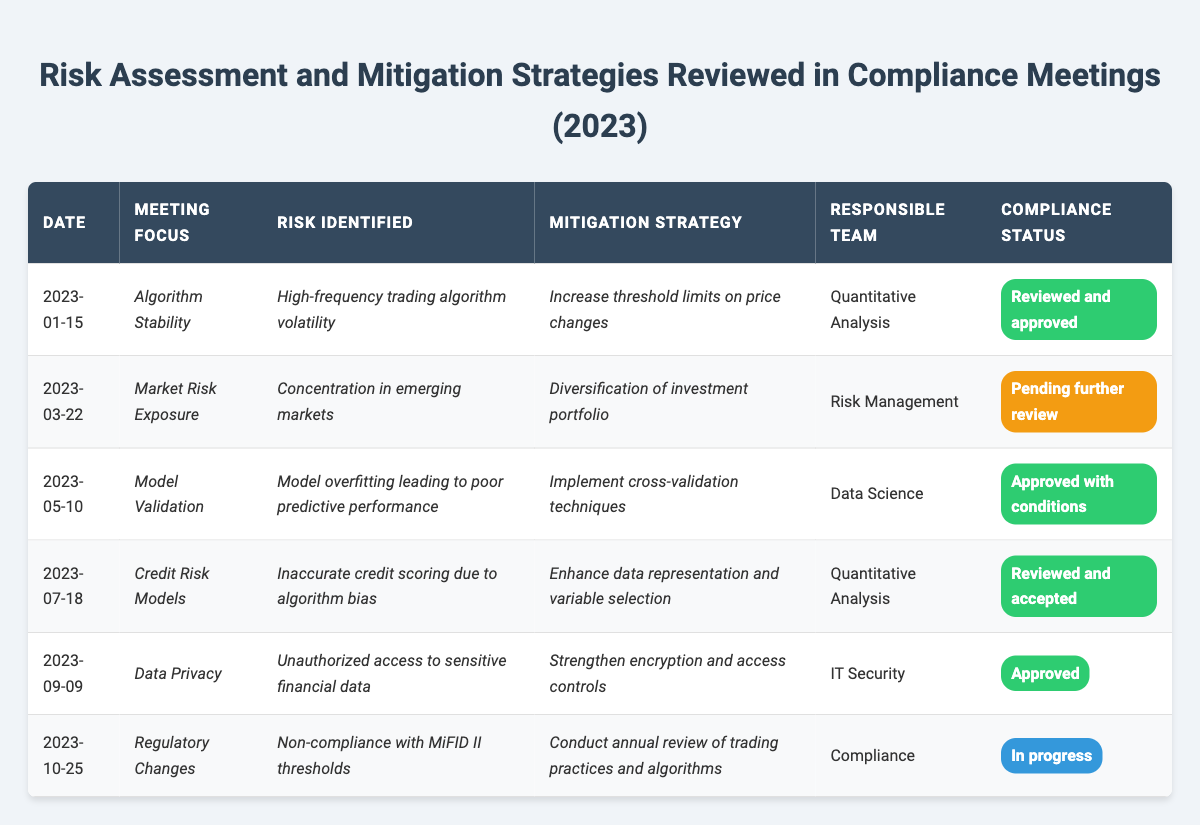What is the date of the meeting that focused on Algorithm Stability? The table shows the entry for Algorithm Stability, which has a date listed as 2023-01-15.
Answer: 2023-01-15 Which risk was identified during the meeting on Data Privacy? The meeting on Data Privacy identified the risk of unauthorized access to sensitive financial data, as detailed in the table.
Answer: Unauthorized access to sensitive financial data How many risks were identified as "Approved" in compliance status? The table indicates that five risks have the compliance status of "Approved" or "Reviewed and accepted" when counting both statuses.
Answer: 5 What was the mitigation strategy for the high-frequency trading algorithm volatility? In the meeting on Algorithm Stability, the mitigation strategy was to increase threshold limits on price changes, according to the table.
Answer: Increase threshold limits on price changes Is the risk identified during the meeting on Regulatory Changes a compliance status of "In progress"? Yes, the compliance status for the risk identified during the meeting on Regulatory Changes is indeed marked as "In progress," based on the table data.
Answer: Yes Which responsible team is associated with the risk of model overfitting? The table shows that the Data Science team is responsible for addressing the risk of model overfitting as outlined in the Model Validation meeting.
Answer: Data Science What is the difference in compliance status between risks reviewed on 2023-05-10 and 2023-01-15? The 2023-01-15 meeting resulted in "Reviewed and approved," while the 2023-05-10 meeting's status is "Approved with conditions," showing a difference in stringency.
Answer: Different statuses (one is approved with conditions) What actions were indicated for addressing the concentration in emerging markets risk? The mitigation strategy discussed for addressing the risk of concentration in emerging markets is diversification of the investment portfolio during the March meeting.
Answer: Diversification of investment portfolio List the focus areas of the meetings that had a compliance status of "Pending further review." The only meeting with a compliance status of "Pending further review" pertains to Market Risk Exposure, focusing on concentration in emerging markets.
Answer: Market Risk Exposure For which identified risk was the mitigation strategy to enhance data representation and variable selection? The table states that this mitigation strategy was identified for the issue of inaccurate credit scoring due to algorithm bias during the Credit Risk Models meeting.
Answer: Inaccurate credit scoring due to algorithm bias 